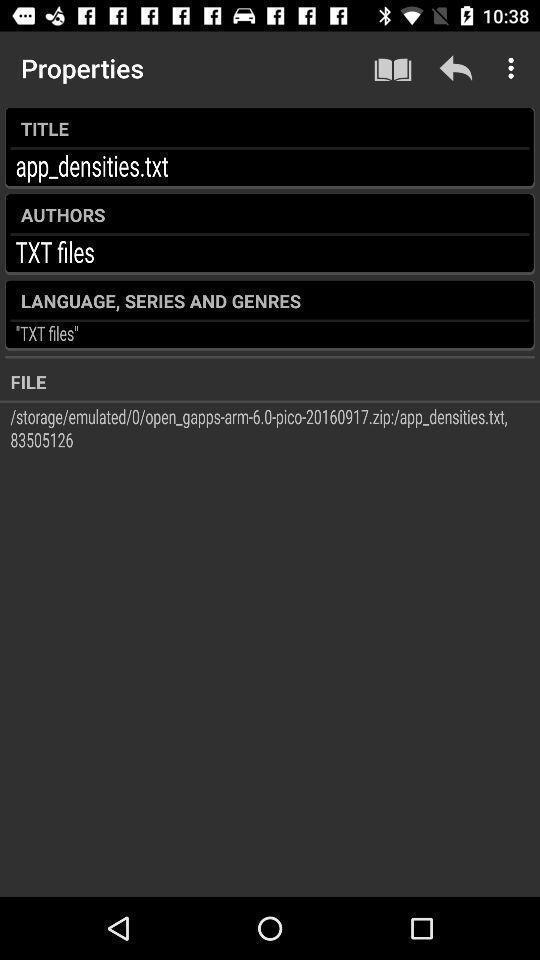Give me a summary of this screen capture. Screen showing properties. 